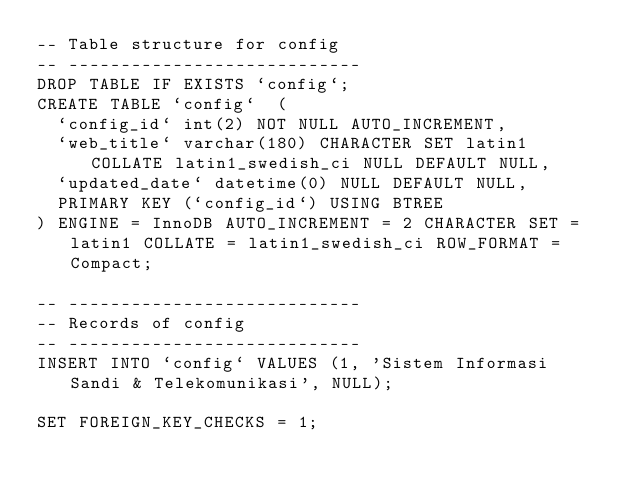<code> <loc_0><loc_0><loc_500><loc_500><_SQL_>-- Table structure for config
-- ----------------------------
DROP TABLE IF EXISTS `config`;
CREATE TABLE `config`  (
  `config_id` int(2) NOT NULL AUTO_INCREMENT,
  `web_title` varchar(180) CHARACTER SET latin1 COLLATE latin1_swedish_ci NULL DEFAULT NULL,
  `updated_date` datetime(0) NULL DEFAULT NULL,
  PRIMARY KEY (`config_id`) USING BTREE
) ENGINE = InnoDB AUTO_INCREMENT = 2 CHARACTER SET = latin1 COLLATE = latin1_swedish_ci ROW_FORMAT = Compact;

-- ----------------------------
-- Records of config
-- ----------------------------
INSERT INTO `config` VALUES (1, 'Sistem Informasi Sandi & Telekomunikasi', NULL);

SET FOREIGN_KEY_CHECKS = 1;
</code> 